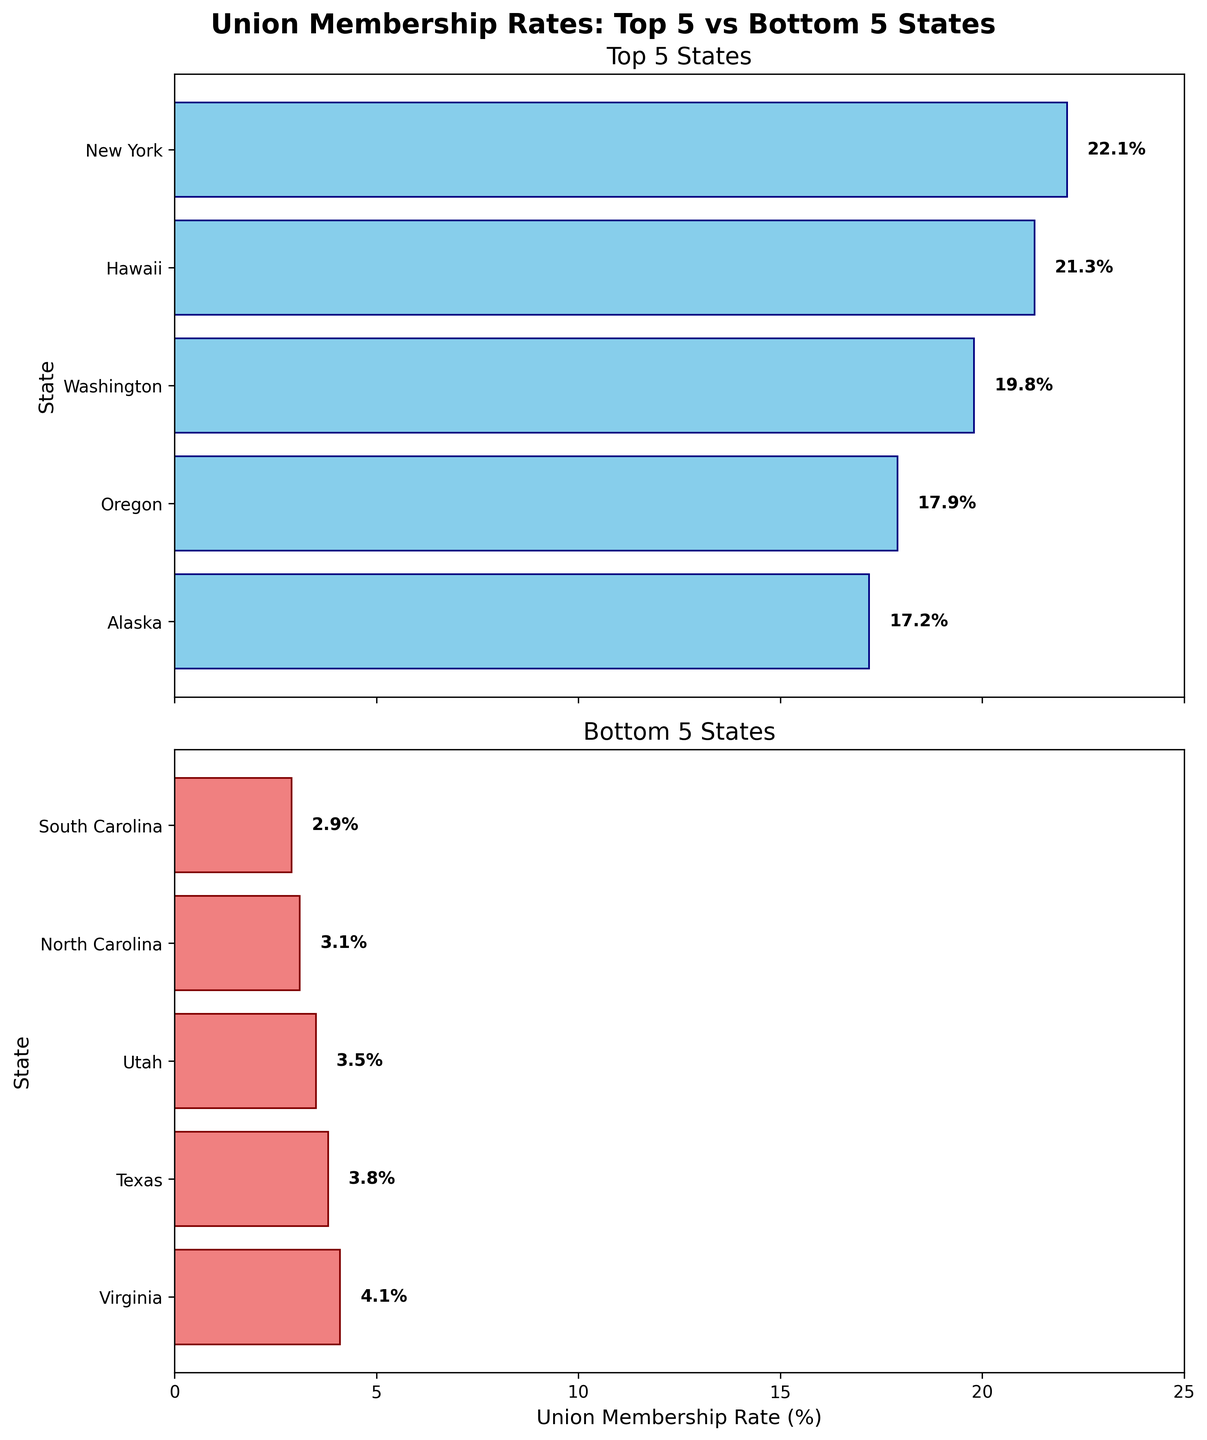What are the titles of the two subplots? The titles are displayed at the top of each subplot. For the top 5 states, it reads "Top 5 States," and for the bottom 5 states, it reads "Bottom 5 States."
Answer: "Top 5 States" and "Bottom 5 States" Which state has the highest union membership rate? In the subplot for the top 5 states, the bar for New York extends the furthest to the right. The label shows 22.1%.
Answer: New York What is the union membership rate for the state with the lowest rate? In the subplot for the bottom 5 states, the bar for South Carolina is the shortest, marked with a label showing 2.9%.
Answer: 2.9% What is the difference in union membership rate between New York and South Carolina? The union membership rate for New York is 22.1%, and for South Carolina, it is 2.9%. The difference is calculated as 22.1 - 2.9.
Answer: 19.2% Which states have a union membership rate below 4%? In the bottom 5 subplot, South Carolina, North Carolina, and Utah have bars extending to 2.9%, 3.1%, and 3.5% respectively.
Answer: South Carolina, North Carolina, Utah What is the range of union membership rates shown in the top 5 states? The highest rate in the top 5 states is New York at 22.1%, and the lowest is Alaska at 17.2%. The range is calculated as 22.1 - 17.2.
Answer: 4.9% How many states have a union membership rate of at least 20%? Among the top 5 states, only New York and Hawaii have rates above 20%.
Answer: 2 Which state in the bottom 5 has the highest union membership rate? In the subplot for the bottom 5 states, Virginia’s bar extends the furthest right, labeled with a 4.1% rate.
Answer: Virginia What is the average union membership rate for the top 5 states? The rates for the top 5 states are 22.1%, 21.3%, 19.8%, 17.9%, and 17.2%. Summing them gives 98.3, and dividing by 5 gives the average.
Answer: 19.66% Which state has a higher union membership rate, Oregon or Texas? Comparing the bars, Oregon's bar extends to 17.9% while Texas's extends to 3.8%.
Answer: Oregon 